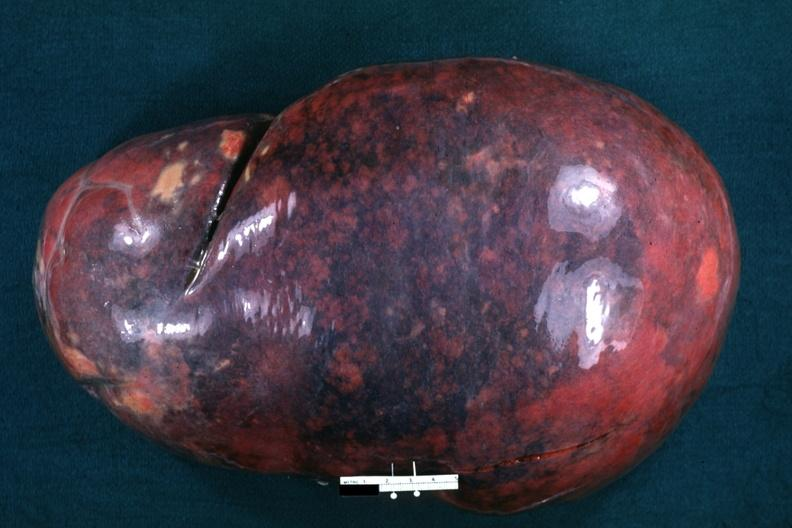s the tumor present?
Answer the question using a single word or phrase. No 